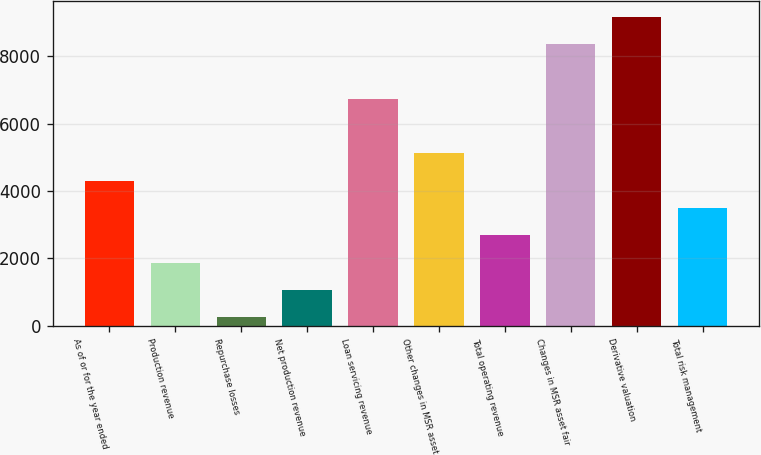Convert chart to OTSL. <chart><loc_0><loc_0><loc_500><loc_500><bar_chart><fcel>As of or for the year ended<fcel>Production revenue<fcel>Repurchase losses<fcel>Net production revenue<fcel>Loan servicing revenue<fcel>Other changes in MSR asset<fcel>Total operating revenue<fcel>Changes in MSR asset fair<fcel>Derivative valuation<fcel>Total risk management<nl><fcel>4309<fcel>1874.8<fcel>252<fcel>1063.4<fcel>6743.2<fcel>5120.4<fcel>2686.2<fcel>8366<fcel>9177.4<fcel>3497.6<nl></chart> 